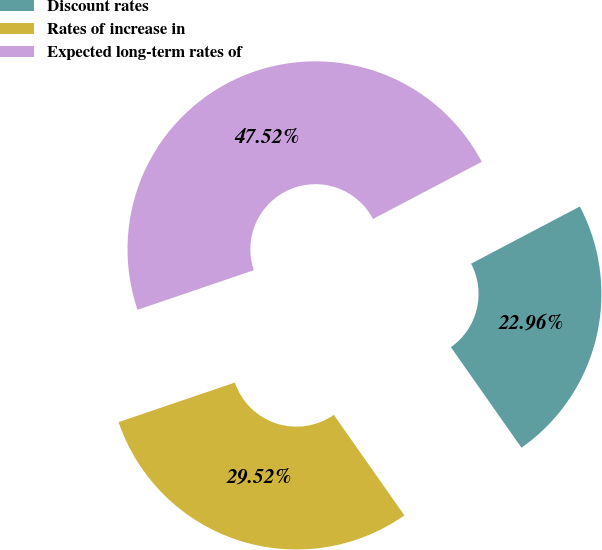Convert chart. <chart><loc_0><loc_0><loc_500><loc_500><pie_chart><fcel>Discount rates<fcel>Rates of increase in<fcel>Expected long-term rates of<nl><fcel>22.96%<fcel>29.52%<fcel>47.52%<nl></chart> 